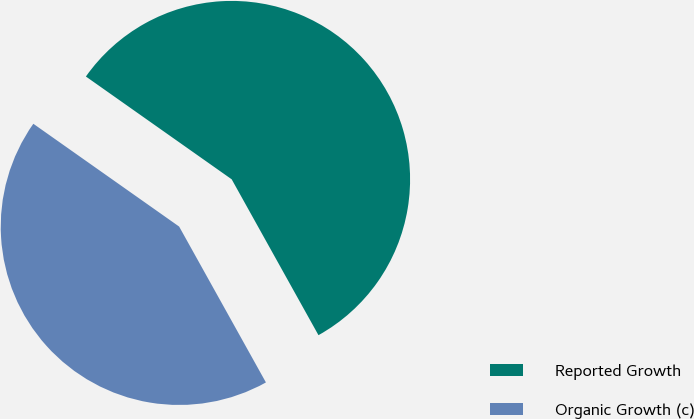Convert chart. <chart><loc_0><loc_0><loc_500><loc_500><pie_chart><fcel>Reported Growth<fcel>Organic Growth (c)<nl><fcel>57.14%<fcel>42.86%<nl></chart> 